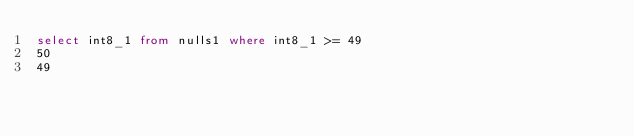<code> <loc_0><loc_0><loc_500><loc_500><_SQL_>select int8_1 from nulls1 where int8_1 >= 49
50
49
</code> 